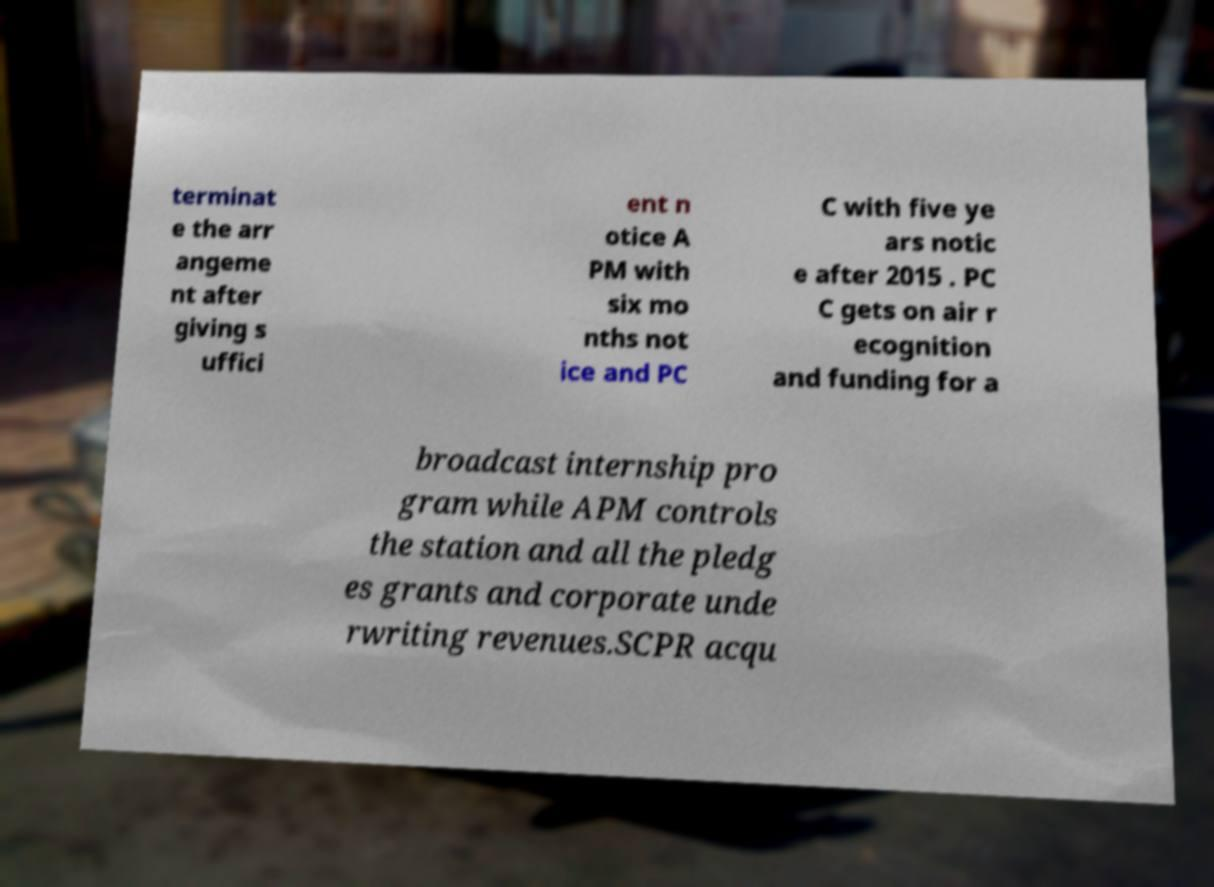Could you assist in decoding the text presented in this image and type it out clearly? terminat e the arr angeme nt after giving s uffici ent n otice A PM with six mo nths not ice and PC C with five ye ars notic e after 2015 . PC C gets on air r ecognition and funding for a broadcast internship pro gram while APM controls the station and all the pledg es grants and corporate unde rwriting revenues.SCPR acqu 